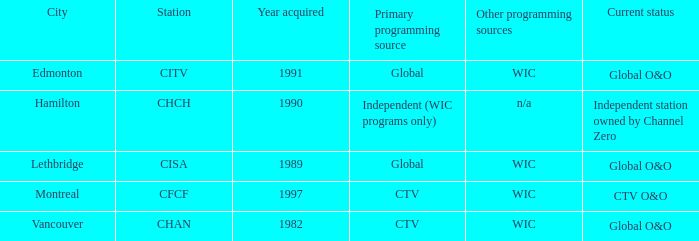Would you mind parsing the complete table? {'header': ['City', 'Station', 'Year acquired', 'Primary programming source', 'Other programming sources', 'Current status'], 'rows': [['Edmonton', 'CITV', '1991', 'Global', 'WIC', 'Global O&O'], ['Hamilton', 'CHCH', '1990', 'Independent (WIC programs only)', 'n/a', 'Independent station owned by Channel Zero'], ['Lethbridge', 'CISA', '1989', 'Global', 'WIC', 'Global O&O'], ['Montreal', 'CFCF', '1997', 'CTV', 'WIC', 'CTV O&O'], ['Vancouver', 'CHAN', '1982', 'CTV', 'WIC', 'Global O&O']]} Which station can be found in edmonton? CITV. 